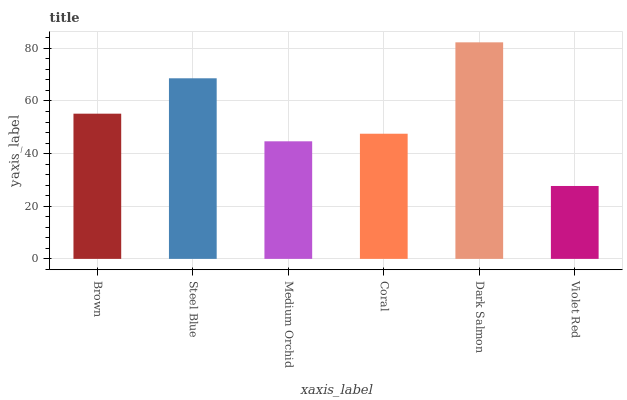Is Violet Red the minimum?
Answer yes or no. Yes. Is Dark Salmon the maximum?
Answer yes or no. Yes. Is Steel Blue the minimum?
Answer yes or no. No. Is Steel Blue the maximum?
Answer yes or no. No. Is Steel Blue greater than Brown?
Answer yes or no. Yes. Is Brown less than Steel Blue?
Answer yes or no. Yes. Is Brown greater than Steel Blue?
Answer yes or no. No. Is Steel Blue less than Brown?
Answer yes or no. No. Is Brown the high median?
Answer yes or no. Yes. Is Coral the low median?
Answer yes or no. Yes. Is Coral the high median?
Answer yes or no. No. Is Dark Salmon the low median?
Answer yes or no. No. 